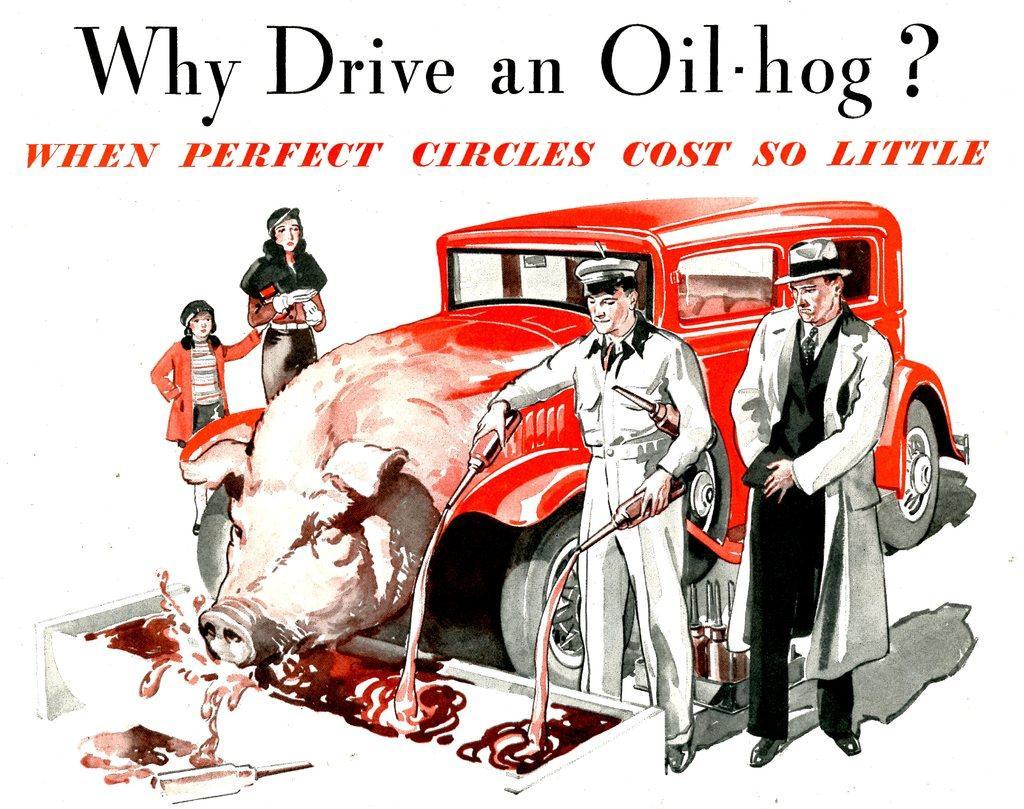Can you describe this image briefly? This is an animated poster. In the center of the picture there are people, bottles, car with the face of pig and some liquid. At the top there is text. 